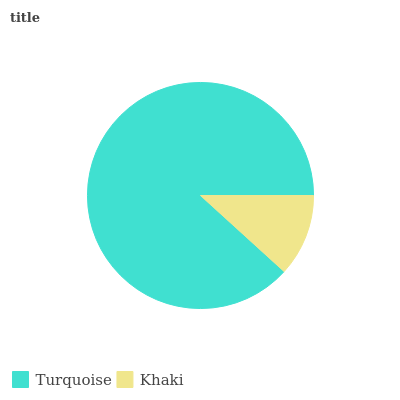Is Khaki the minimum?
Answer yes or no. Yes. Is Turquoise the maximum?
Answer yes or no. Yes. Is Khaki the maximum?
Answer yes or no. No. Is Turquoise greater than Khaki?
Answer yes or no. Yes. Is Khaki less than Turquoise?
Answer yes or no. Yes. Is Khaki greater than Turquoise?
Answer yes or no. No. Is Turquoise less than Khaki?
Answer yes or no. No. Is Turquoise the high median?
Answer yes or no. Yes. Is Khaki the low median?
Answer yes or no. Yes. Is Khaki the high median?
Answer yes or no. No. Is Turquoise the low median?
Answer yes or no. No. 